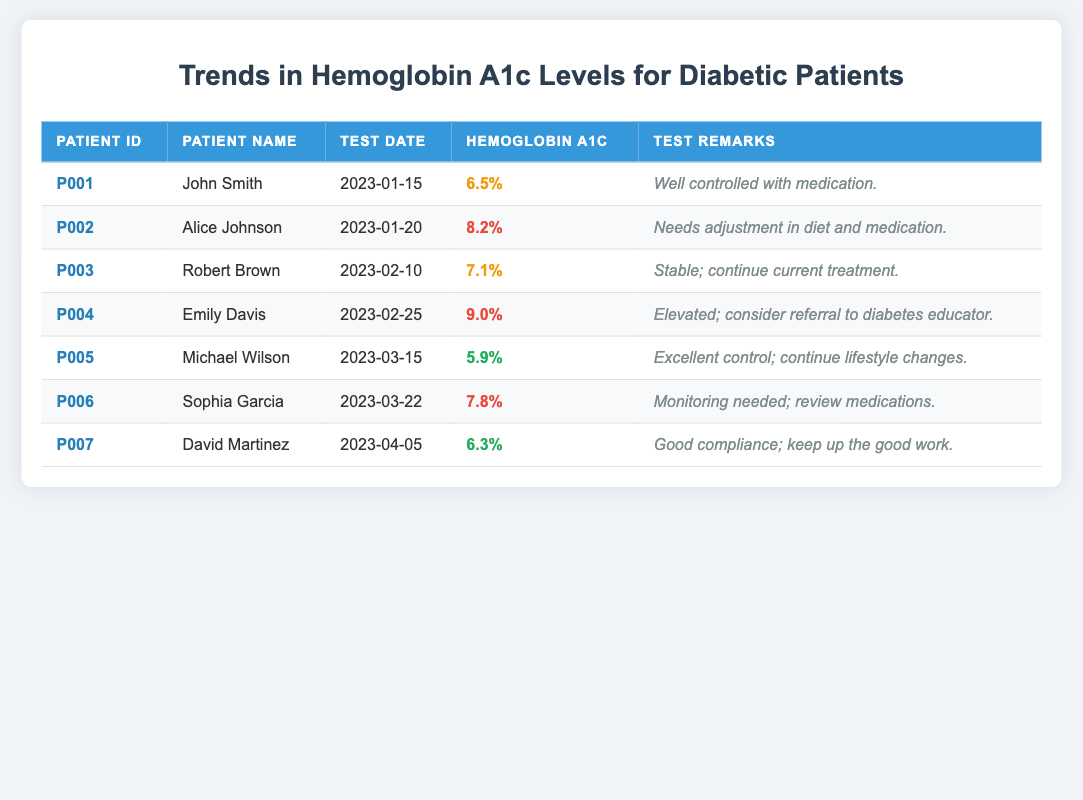What is the Hemoglobin A1c level for Michael Wilson? The table shows that Michael Wilson's Hemoglobin A1c level is listed under "Hemoglobin A1c" for his entry. Specifically, it states 5.9%.
Answer: 5.9% Which patient has the highest Hemoglobin A1c level? The highest Hemoglobin A1c level can be found by comparing the values in the table. Emily Davis has a level of 9.0%, which is higher than any other patient listed.
Answer: Emily Davis What are the test remarks for Alice Johnson? Referring to Alice Johnson's entry, the test remarks are stated as "Needs adjustment in diet and medication."
Answer: Needs adjustment in diet and medication Are there any patients with a Hemoglobin A1c level below 6%? By looking at the Hemoglobin A1c levels presented in the table, the lowest level is 5.9% for Michael Wilson, which qualifies as below 6%. Therefore, there are patients with levels below 6%.
Answer: Yes What is the average Hemoglobin A1c level for the patients listed? To find the average, sum all the Hemoglobin A1c levels: (6.5 + 8.2 + 7.1 + 9.0 + 5.9 + 7.8 + 6.3) = 50.8. There are 7 patients, so the average is 50.8 / 7 = 7.257, rounded to three decimal places it is approximately 7.26.
Answer: 7.26 Which patient showed improvement in their Hemoglobin A1c levels compared to their previous results? Improvement can be determined by looking at trends in the data. Since the table does not provide historical data, but David Martinez has the lowest recent score (6.3%) compared to his past scores, implies improvement in control.
Answer: Yes What are the names of patients with Hemoglobin A1c levels categorized as high? The table identifies high Hemoglobin A1c levels, specifically for Alice Johnson (8.2%), Emily Davis (9.0%), and Sophia Garcia (7.8%). Listing their names gives Alice Johnson, Emily Davis, and Sophia Garcia.
Answer: Alice Johnson, Emily Davis, Sophia Garcia Is there a patient who needs monitoring for their Hemoglobin A1c levels? Sophia Garcia's test remarks indicate the need for monitoring: "Monitoring needed; review medications." Therefore, there is indeed a patient that requires monitoring.
Answer: Yes Who has a Hemoglobin A1c level in the normal range? Based on the table, Michael Wilson (5.9%) and David Martinez (6.3%) both have levels categorized as normal. Thus, these two patients fall within the normal range.
Answer: Michael Wilson, David Martinez 